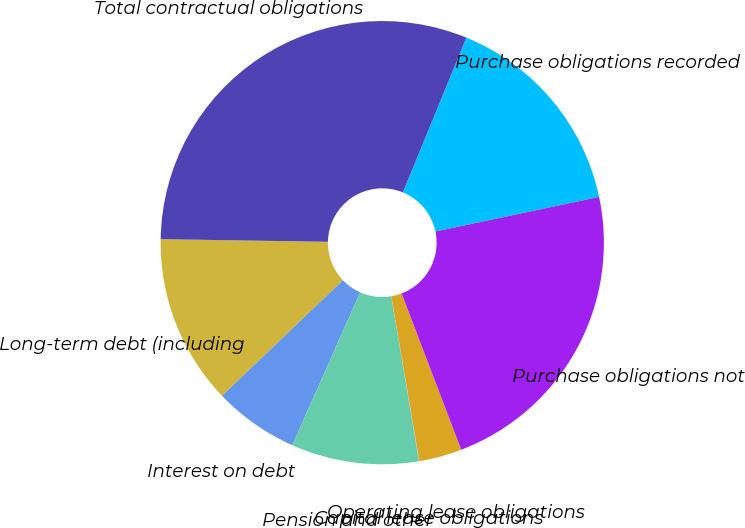<chart> <loc_0><loc_0><loc_500><loc_500><pie_chart><fcel>Long-term debt (including<fcel>Interest on debt<fcel>Pension and other<fcel>Capital lease obligations<fcel>Operating lease obligations<fcel>Purchase obligations not<fcel>Purchase obligations recorded<fcel>Total contractual obligations<nl><fcel>12.39%<fcel>6.21%<fcel>9.3%<fcel>0.03%<fcel>3.12%<fcel>22.51%<fcel>15.49%<fcel>30.94%<nl></chart> 